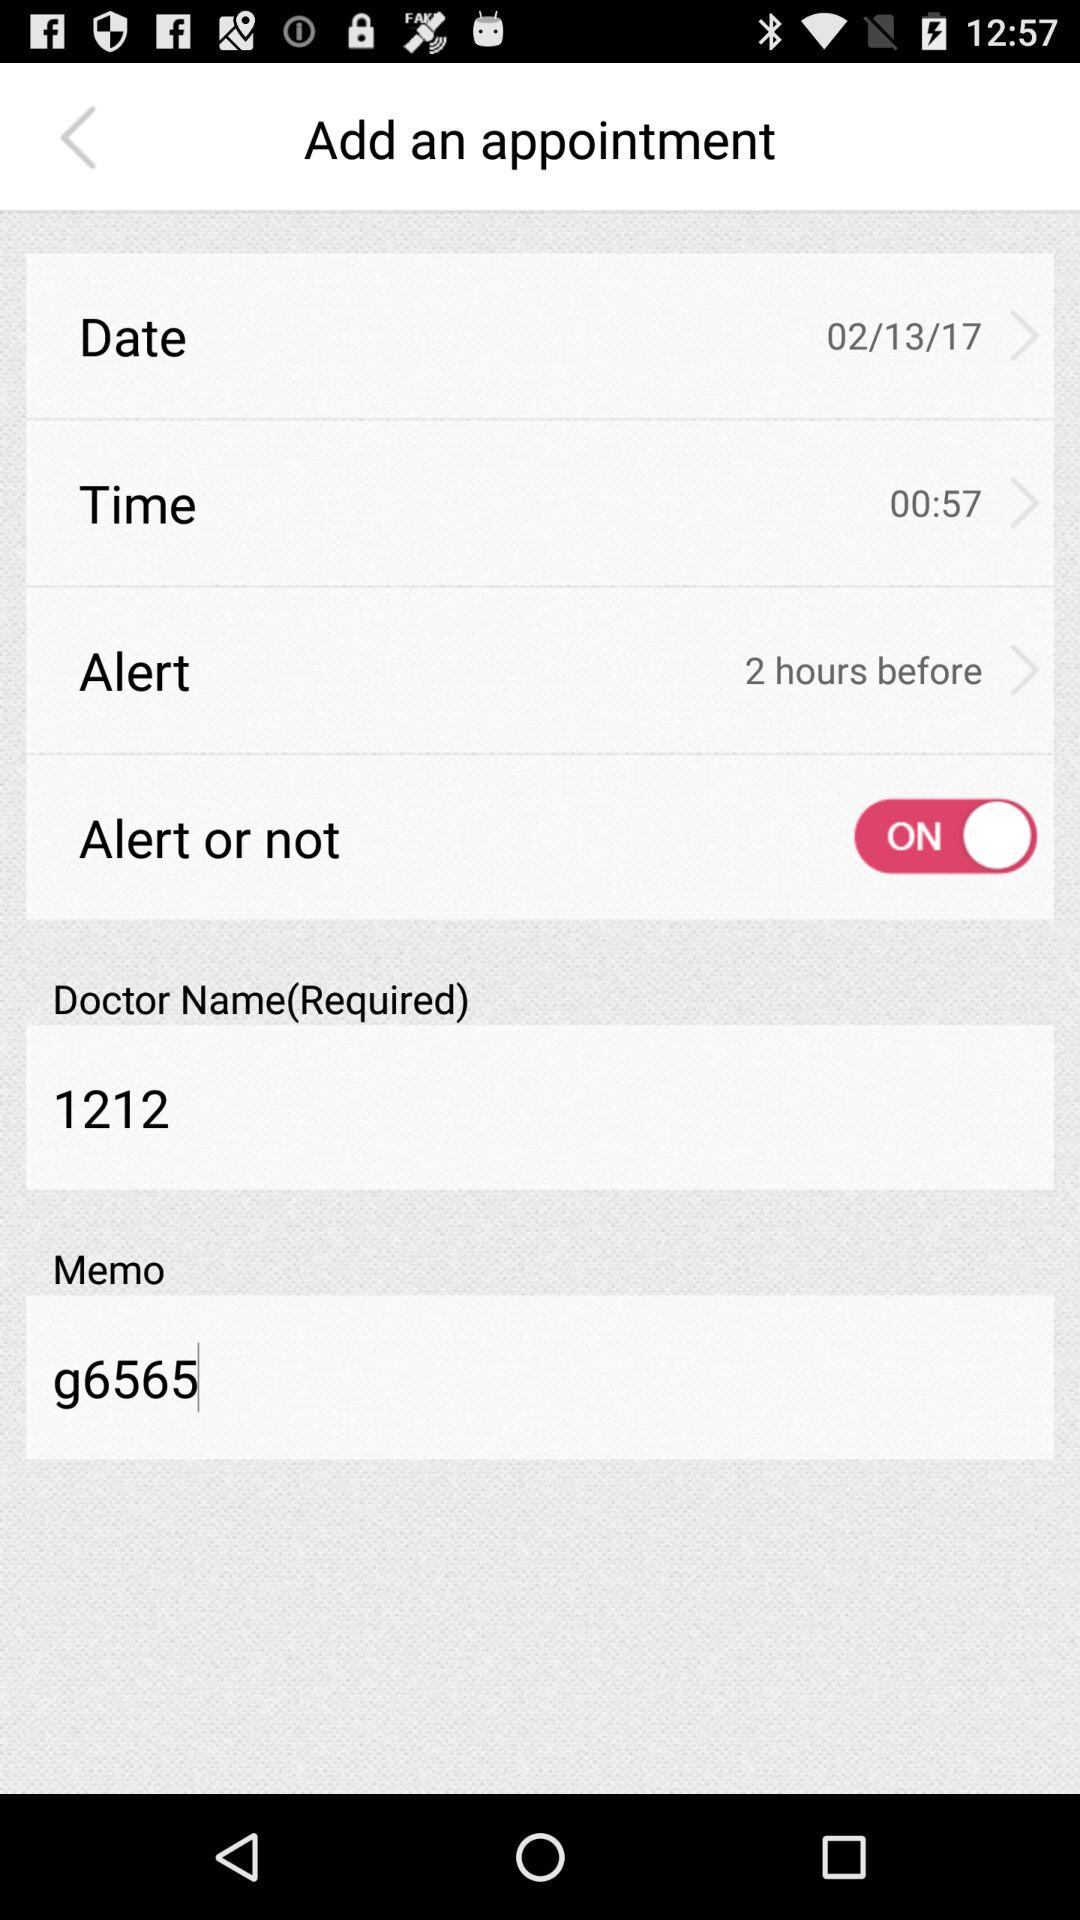What is the selected time? The time is "00:57". 